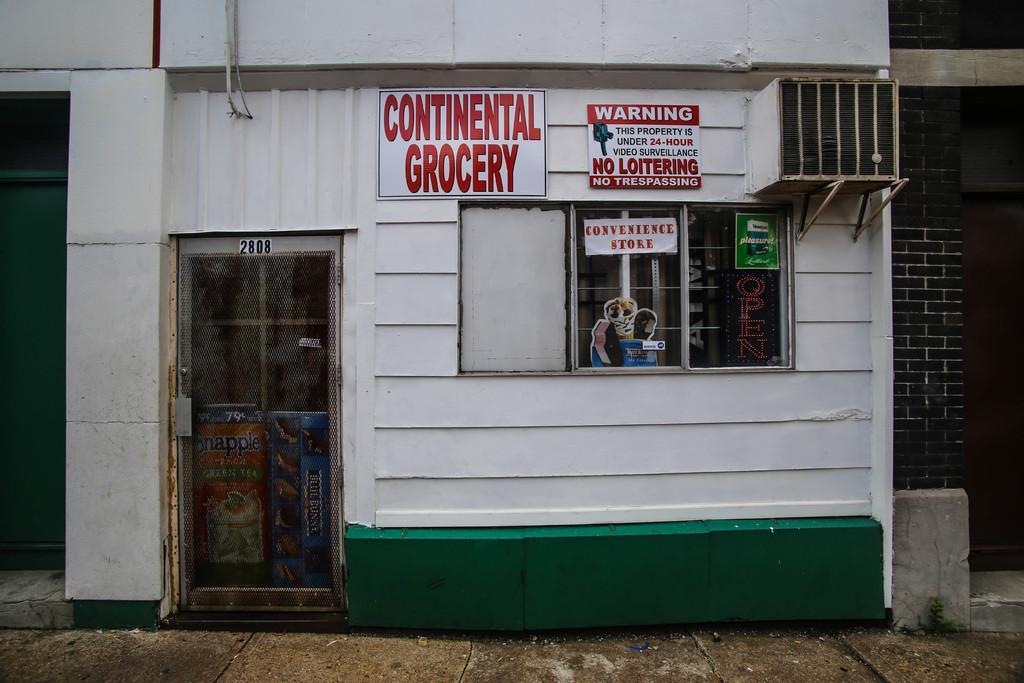Describe this image in one or two sentences. In this image in the center there is a building, and on the building there are some boards on the boards there is text and there is a glass door. On the door there are some posters and there is a door through the door we could see some bags and there is object, at the bottom there is walkway. 